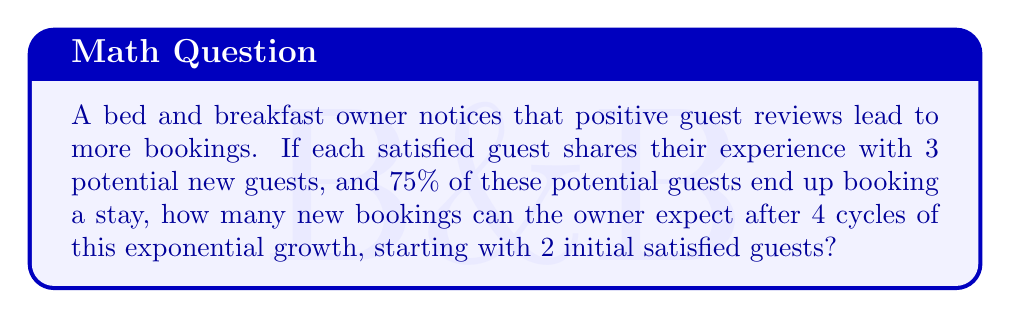Can you solve this math problem? Let's break this down step-by-step:

1) First, we need to identify the growth factor for each cycle:
   - Each guest shares with 3 people
   - 75% of these book a stay
   - So, the growth factor is: $3 \times 0.75 = 2.25$

2) We start with 2 initial satisfied guests, and we want to calculate the result after 4 cycles.

3) The formula for exponential growth is:
   $$ A = P \times r^n $$
   Where:
   $A$ = final amount
   $P$ = initial amount
   $r$ = growth factor
   $n$ = number of cycles

4) Plugging in our values:
   $$ A = 2 \times 2.25^4 $$

5) Let's calculate this:
   $$ A = 2 \times (2.25 \times 2.25 \times 2.25 \times 2.25) $$
   $$ A = 2 \times 25.6289 $$
   $$ A = 51.2578 $$

6) Since we can't have fractional bookings, we round down to the nearest whole number.

Therefore, the bed and breakfast owner can expect 51 new bookings after 4 cycles of this exponential growth.
Answer: 51 new bookings 